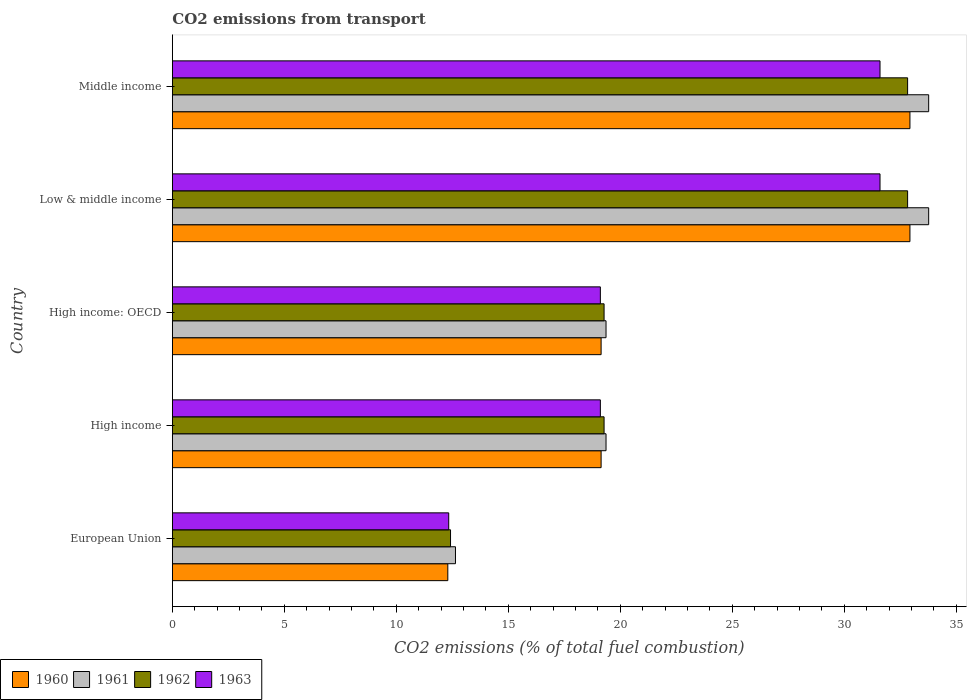How many groups of bars are there?
Give a very brief answer. 5. Are the number of bars on each tick of the Y-axis equal?
Offer a terse response. Yes. How many bars are there on the 5th tick from the top?
Your answer should be compact. 4. How many bars are there on the 1st tick from the bottom?
Keep it short and to the point. 4. What is the label of the 3rd group of bars from the top?
Offer a terse response. High income: OECD. In how many cases, is the number of bars for a given country not equal to the number of legend labels?
Keep it short and to the point. 0. What is the total CO2 emitted in 1960 in European Union?
Ensure brevity in your answer.  12.3. Across all countries, what is the maximum total CO2 emitted in 1963?
Offer a very short reply. 31.59. Across all countries, what is the minimum total CO2 emitted in 1961?
Your answer should be very brief. 12.64. In which country was the total CO2 emitted in 1960 minimum?
Offer a very short reply. European Union. What is the total total CO2 emitted in 1962 in the graph?
Ensure brevity in your answer.  116.61. What is the difference between the total CO2 emitted in 1961 in European Union and that in Low & middle income?
Offer a very short reply. -21.13. What is the difference between the total CO2 emitted in 1960 in High income and the total CO2 emitted in 1961 in High income: OECD?
Give a very brief answer. -0.22. What is the average total CO2 emitted in 1962 per country?
Provide a short and direct response. 23.32. What is the difference between the total CO2 emitted in 1963 and total CO2 emitted in 1961 in High income: OECD?
Your response must be concise. -0.25. In how many countries, is the total CO2 emitted in 1960 greater than 13 ?
Make the answer very short. 4. What is the ratio of the total CO2 emitted in 1963 in European Union to that in High income?
Ensure brevity in your answer.  0.65. Is the total CO2 emitted in 1963 in European Union less than that in Low & middle income?
Ensure brevity in your answer.  Yes. Is the difference between the total CO2 emitted in 1963 in European Union and High income greater than the difference between the total CO2 emitted in 1961 in European Union and High income?
Your response must be concise. No. What is the difference between the highest and the second highest total CO2 emitted in 1962?
Offer a terse response. 0. What is the difference between the highest and the lowest total CO2 emitted in 1961?
Offer a very short reply. 21.13. Is the sum of the total CO2 emitted in 1962 in High income: OECD and Middle income greater than the maximum total CO2 emitted in 1963 across all countries?
Offer a terse response. Yes. Is it the case that in every country, the sum of the total CO2 emitted in 1962 and total CO2 emitted in 1963 is greater than the sum of total CO2 emitted in 1961 and total CO2 emitted in 1960?
Give a very brief answer. No. What does the 3rd bar from the top in High income: OECD represents?
Provide a succinct answer. 1961. How many bars are there?
Offer a very short reply. 20. Are all the bars in the graph horizontal?
Your answer should be very brief. Yes. How many countries are there in the graph?
Keep it short and to the point. 5. Are the values on the major ticks of X-axis written in scientific E-notation?
Your answer should be very brief. No. Does the graph contain any zero values?
Offer a terse response. No. Does the graph contain grids?
Offer a very short reply. No. What is the title of the graph?
Your answer should be compact. CO2 emissions from transport. Does "2009" appear as one of the legend labels in the graph?
Ensure brevity in your answer.  No. What is the label or title of the X-axis?
Give a very brief answer. CO2 emissions (% of total fuel combustion). What is the label or title of the Y-axis?
Your response must be concise. Country. What is the CO2 emissions (% of total fuel combustion) of 1960 in European Union?
Keep it short and to the point. 12.3. What is the CO2 emissions (% of total fuel combustion) in 1961 in European Union?
Offer a terse response. 12.64. What is the CO2 emissions (% of total fuel combustion) in 1962 in European Union?
Your response must be concise. 12.42. What is the CO2 emissions (% of total fuel combustion) in 1963 in European Union?
Ensure brevity in your answer.  12.34. What is the CO2 emissions (% of total fuel combustion) in 1960 in High income?
Make the answer very short. 19.14. What is the CO2 emissions (% of total fuel combustion) of 1961 in High income?
Provide a succinct answer. 19.36. What is the CO2 emissions (% of total fuel combustion) of 1962 in High income?
Your response must be concise. 19.27. What is the CO2 emissions (% of total fuel combustion) in 1963 in High income?
Provide a short and direct response. 19.11. What is the CO2 emissions (% of total fuel combustion) in 1960 in High income: OECD?
Your answer should be very brief. 19.14. What is the CO2 emissions (% of total fuel combustion) of 1961 in High income: OECD?
Keep it short and to the point. 19.36. What is the CO2 emissions (% of total fuel combustion) in 1962 in High income: OECD?
Ensure brevity in your answer.  19.27. What is the CO2 emissions (% of total fuel combustion) of 1963 in High income: OECD?
Provide a short and direct response. 19.11. What is the CO2 emissions (% of total fuel combustion) in 1960 in Low & middle income?
Ensure brevity in your answer.  32.93. What is the CO2 emissions (% of total fuel combustion) in 1961 in Low & middle income?
Your answer should be compact. 33.76. What is the CO2 emissions (% of total fuel combustion) in 1962 in Low & middle income?
Your answer should be compact. 32.82. What is the CO2 emissions (% of total fuel combustion) of 1963 in Low & middle income?
Your answer should be compact. 31.59. What is the CO2 emissions (% of total fuel combustion) of 1960 in Middle income?
Offer a terse response. 32.93. What is the CO2 emissions (% of total fuel combustion) in 1961 in Middle income?
Provide a short and direct response. 33.76. What is the CO2 emissions (% of total fuel combustion) of 1962 in Middle income?
Offer a terse response. 32.82. What is the CO2 emissions (% of total fuel combustion) in 1963 in Middle income?
Provide a succinct answer. 31.59. Across all countries, what is the maximum CO2 emissions (% of total fuel combustion) of 1960?
Your answer should be very brief. 32.93. Across all countries, what is the maximum CO2 emissions (% of total fuel combustion) in 1961?
Offer a very short reply. 33.76. Across all countries, what is the maximum CO2 emissions (% of total fuel combustion) in 1962?
Offer a very short reply. 32.82. Across all countries, what is the maximum CO2 emissions (% of total fuel combustion) in 1963?
Your answer should be compact. 31.59. Across all countries, what is the minimum CO2 emissions (% of total fuel combustion) of 1960?
Offer a very short reply. 12.3. Across all countries, what is the minimum CO2 emissions (% of total fuel combustion) in 1961?
Provide a short and direct response. 12.64. Across all countries, what is the minimum CO2 emissions (% of total fuel combustion) of 1962?
Make the answer very short. 12.42. Across all countries, what is the minimum CO2 emissions (% of total fuel combustion) of 1963?
Your answer should be compact. 12.34. What is the total CO2 emissions (% of total fuel combustion) of 1960 in the graph?
Provide a short and direct response. 116.44. What is the total CO2 emissions (% of total fuel combustion) in 1961 in the graph?
Offer a very short reply. 118.89. What is the total CO2 emissions (% of total fuel combustion) in 1962 in the graph?
Provide a succinct answer. 116.61. What is the total CO2 emissions (% of total fuel combustion) in 1963 in the graph?
Your response must be concise. 113.74. What is the difference between the CO2 emissions (% of total fuel combustion) of 1960 in European Union and that in High income?
Your answer should be compact. -6.84. What is the difference between the CO2 emissions (% of total fuel combustion) of 1961 in European Union and that in High income?
Ensure brevity in your answer.  -6.72. What is the difference between the CO2 emissions (% of total fuel combustion) in 1962 in European Union and that in High income?
Your answer should be very brief. -6.86. What is the difference between the CO2 emissions (% of total fuel combustion) of 1963 in European Union and that in High income?
Provide a short and direct response. -6.77. What is the difference between the CO2 emissions (% of total fuel combustion) of 1960 in European Union and that in High income: OECD?
Make the answer very short. -6.84. What is the difference between the CO2 emissions (% of total fuel combustion) of 1961 in European Union and that in High income: OECD?
Give a very brief answer. -6.72. What is the difference between the CO2 emissions (% of total fuel combustion) of 1962 in European Union and that in High income: OECD?
Ensure brevity in your answer.  -6.86. What is the difference between the CO2 emissions (% of total fuel combustion) in 1963 in European Union and that in High income: OECD?
Offer a very short reply. -6.77. What is the difference between the CO2 emissions (% of total fuel combustion) in 1960 in European Union and that in Low & middle income?
Your answer should be compact. -20.63. What is the difference between the CO2 emissions (% of total fuel combustion) of 1961 in European Union and that in Low & middle income?
Give a very brief answer. -21.13. What is the difference between the CO2 emissions (% of total fuel combustion) of 1962 in European Union and that in Low & middle income?
Give a very brief answer. -20.41. What is the difference between the CO2 emissions (% of total fuel combustion) in 1963 in European Union and that in Low & middle income?
Your answer should be very brief. -19.25. What is the difference between the CO2 emissions (% of total fuel combustion) in 1960 in European Union and that in Middle income?
Provide a succinct answer. -20.63. What is the difference between the CO2 emissions (% of total fuel combustion) in 1961 in European Union and that in Middle income?
Offer a very short reply. -21.13. What is the difference between the CO2 emissions (% of total fuel combustion) in 1962 in European Union and that in Middle income?
Offer a terse response. -20.41. What is the difference between the CO2 emissions (% of total fuel combustion) in 1963 in European Union and that in Middle income?
Offer a terse response. -19.25. What is the difference between the CO2 emissions (% of total fuel combustion) in 1962 in High income and that in High income: OECD?
Give a very brief answer. 0. What is the difference between the CO2 emissions (% of total fuel combustion) in 1963 in High income and that in High income: OECD?
Your answer should be compact. 0. What is the difference between the CO2 emissions (% of total fuel combustion) in 1960 in High income and that in Low & middle income?
Offer a very short reply. -13.79. What is the difference between the CO2 emissions (% of total fuel combustion) of 1961 in High income and that in Low & middle income?
Offer a very short reply. -14.4. What is the difference between the CO2 emissions (% of total fuel combustion) in 1962 in High income and that in Low & middle income?
Provide a short and direct response. -13.55. What is the difference between the CO2 emissions (% of total fuel combustion) in 1963 in High income and that in Low & middle income?
Make the answer very short. -12.48. What is the difference between the CO2 emissions (% of total fuel combustion) of 1960 in High income and that in Middle income?
Provide a succinct answer. -13.79. What is the difference between the CO2 emissions (% of total fuel combustion) of 1961 in High income and that in Middle income?
Offer a terse response. -14.4. What is the difference between the CO2 emissions (% of total fuel combustion) in 1962 in High income and that in Middle income?
Ensure brevity in your answer.  -13.55. What is the difference between the CO2 emissions (% of total fuel combustion) in 1963 in High income and that in Middle income?
Your answer should be compact. -12.48. What is the difference between the CO2 emissions (% of total fuel combustion) of 1960 in High income: OECD and that in Low & middle income?
Offer a terse response. -13.79. What is the difference between the CO2 emissions (% of total fuel combustion) in 1961 in High income: OECD and that in Low & middle income?
Your response must be concise. -14.4. What is the difference between the CO2 emissions (% of total fuel combustion) in 1962 in High income: OECD and that in Low & middle income?
Offer a terse response. -13.55. What is the difference between the CO2 emissions (% of total fuel combustion) in 1963 in High income: OECD and that in Low & middle income?
Keep it short and to the point. -12.48. What is the difference between the CO2 emissions (% of total fuel combustion) of 1960 in High income: OECD and that in Middle income?
Your response must be concise. -13.79. What is the difference between the CO2 emissions (% of total fuel combustion) in 1961 in High income: OECD and that in Middle income?
Offer a very short reply. -14.4. What is the difference between the CO2 emissions (% of total fuel combustion) in 1962 in High income: OECD and that in Middle income?
Offer a very short reply. -13.55. What is the difference between the CO2 emissions (% of total fuel combustion) in 1963 in High income: OECD and that in Middle income?
Offer a terse response. -12.48. What is the difference between the CO2 emissions (% of total fuel combustion) of 1961 in Low & middle income and that in Middle income?
Your response must be concise. 0. What is the difference between the CO2 emissions (% of total fuel combustion) of 1960 in European Union and the CO2 emissions (% of total fuel combustion) of 1961 in High income?
Provide a succinct answer. -7.06. What is the difference between the CO2 emissions (% of total fuel combustion) of 1960 in European Union and the CO2 emissions (% of total fuel combustion) of 1962 in High income?
Provide a short and direct response. -6.98. What is the difference between the CO2 emissions (% of total fuel combustion) in 1960 in European Union and the CO2 emissions (% of total fuel combustion) in 1963 in High income?
Ensure brevity in your answer.  -6.81. What is the difference between the CO2 emissions (% of total fuel combustion) in 1961 in European Union and the CO2 emissions (% of total fuel combustion) in 1962 in High income?
Keep it short and to the point. -6.64. What is the difference between the CO2 emissions (% of total fuel combustion) in 1961 in European Union and the CO2 emissions (% of total fuel combustion) in 1963 in High income?
Your response must be concise. -6.47. What is the difference between the CO2 emissions (% of total fuel combustion) of 1962 in European Union and the CO2 emissions (% of total fuel combustion) of 1963 in High income?
Offer a terse response. -6.69. What is the difference between the CO2 emissions (% of total fuel combustion) of 1960 in European Union and the CO2 emissions (% of total fuel combustion) of 1961 in High income: OECD?
Your answer should be very brief. -7.06. What is the difference between the CO2 emissions (% of total fuel combustion) in 1960 in European Union and the CO2 emissions (% of total fuel combustion) in 1962 in High income: OECD?
Ensure brevity in your answer.  -6.98. What is the difference between the CO2 emissions (% of total fuel combustion) in 1960 in European Union and the CO2 emissions (% of total fuel combustion) in 1963 in High income: OECD?
Keep it short and to the point. -6.81. What is the difference between the CO2 emissions (% of total fuel combustion) in 1961 in European Union and the CO2 emissions (% of total fuel combustion) in 1962 in High income: OECD?
Your answer should be compact. -6.64. What is the difference between the CO2 emissions (% of total fuel combustion) in 1961 in European Union and the CO2 emissions (% of total fuel combustion) in 1963 in High income: OECD?
Your answer should be compact. -6.47. What is the difference between the CO2 emissions (% of total fuel combustion) of 1962 in European Union and the CO2 emissions (% of total fuel combustion) of 1963 in High income: OECD?
Make the answer very short. -6.69. What is the difference between the CO2 emissions (% of total fuel combustion) in 1960 in European Union and the CO2 emissions (% of total fuel combustion) in 1961 in Low & middle income?
Your answer should be very brief. -21.47. What is the difference between the CO2 emissions (% of total fuel combustion) in 1960 in European Union and the CO2 emissions (% of total fuel combustion) in 1962 in Low & middle income?
Keep it short and to the point. -20.53. What is the difference between the CO2 emissions (% of total fuel combustion) in 1960 in European Union and the CO2 emissions (% of total fuel combustion) in 1963 in Low & middle income?
Provide a succinct answer. -19.29. What is the difference between the CO2 emissions (% of total fuel combustion) in 1961 in European Union and the CO2 emissions (% of total fuel combustion) in 1962 in Low & middle income?
Your answer should be very brief. -20.19. What is the difference between the CO2 emissions (% of total fuel combustion) of 1961 in European Union and the CO2 emissions (% of total fuel combustion) of 1963 in Low & middle income?
Make the answer very short. -18.95. What is the difference between the CO2 emissions (% of total fuel combustion) of 1962 in European Union and the CO2 emissions (% of total fuel combustion) of 1963 in Low & middle income?
Offer a very short reply. -19.17. What is the difference between the CO2 emissions (% of total fuel combustion) of 1960 in European Union and the CO2 emissions (% of total fuel combustion) of 1961 in Middle income?
Offer a very short reply. -21.47. What is the difference between the CO2 emissions (% of total fuel combustion) in 1960 in European Union and the CO2 emissions (% of total fuel combustion) in 1962 in Middle income?
Provide a succinct answer. -20.53. What is the difference between the CO2 emissions (% of total fuel combustion) of 1960 in European Union and the CO2 emissions (% of total fuel combustion) of 1963 in Middle income?
Your answer should be very brief. -19.29. What is the difference between the CO2 emissions (% of total fuel combustion) in 1961 in European Union and the CO2 emissions (% of total fuel combustion) in 1962 in Middle income?
Make the answer very short. -20.19. What is the difference between the CO2 emissions (% of total fuel combustion) in 1961 in European Union and the CO2 emissions (% of total fuel combustion) in 1963 in Middle income?
Your answer should be compact. -18.95. What is the difference between the CO2 emissions (% of total fuel combustion) of 1962 in European Union and the CO2 emissions (% of total fuel combustion) of 1963 in Middle income?
Your answer should be compact. -19.17. What is the difference between the CO2 emissions (% of total fuel combustion) of 1960 in High income and the CO2 emissions (% of total fuel combustion) of 1961 in High income: OECD?
Offer a terse response. -0.22. What is the difference between the CO2 emissions (% of total fuel combustion) of 1960 in High income and the CO2 emissions (% of total fuel combustion) of 1962 in High income: OECD?
Your response must be concise. -0.13. What is the difference between the CO2 emissions (% of total fuel combustion) of 1960 in High income and the CO2 emissions (% of total fuel combustion) of 1963 in High income: OECD?
Your answer should be very brief. 0.03. What is the difference between the CO2 emissions (% of total fuel combustion) in 1961 in High income and the CO2 emissions (% of total fuel combustion) in 1962 in High income: OECD?
Your answer should be compact. 0.09. What is the difference between the CO2 emissions (% of total fuel combustion) of 1961 in High income and the CO2 emissions (% of total fuel combustion) of 1963 in High income: OECD?
Provide a short and direct response. 0.25. What is the difference between the CO2 emissions (% of total fuel combustion) of 1962 in High income and the CO2 emissions (% of total fuel combustion) of 1963 in High income: OECD?
Give a very brief answer. 0.17. What is the difference between the CO2 emissions (% of total fuel combustion) of 1960 in High income and the CO2 emissions (% of total fuel combustion) of 1961 in Low & middle income?
Keep it short and to the point. -14.62. What is the difference between the CO2 emissions (% of total fuel combustion) in 1960 in High income and the CO2 emissions (% of total fuel combustion) in 1962 in Low & middle income?
Make the answer very short. -13.68. What is the difference between the CO2 emissions (% of total fuel combustion) in 1960 in High income and the CO2 emissions (% of total fuel combustion) in 1963 in Low & middle income?
Your response must be concise. -12.45. What is the difference between the CO2 emissions (% of total fuel combustion) in 1961 in High income and the CO2 emissions (% of total fuel combustion) in 1962 in Low & middle income?
Offer a very short reply. -13.46. What is the difference between the CO2 emissions (% of total fuel combustion) of 1961 in High income and the CO2 emissions (% of total fuel combustion) of 1963 in Low & middle income?
Make the answer very short. -12.23. What is the difference between the CO2 emissions (% of total fuel combustion) of 1962 in High income and the CO2 emissions (% of total fuel combustion) of 1963 in Low & middle income?
Keep it short and to the point. -12.32. What is the difference between the CO2 emissions (% of total fuel combustion) in 1960 in High income and the CO2 emissions (% of total fuel combustion) in 1961 in Middle income?
Your answer should be compact. -14.62. What is the difference between the CO2 emissions (% of total fuel combustion) in 1960 in High income and the CO2 emissions (% of total fuel combustion) in 1962 in Middle income?
Offer a terse response. -13.68. What is the difference between the CO2 emissions (% of total fuel combustion) of 1960 in High income and the CO2 emissions (% of total fuel combustion) of 1963 in Middle income?
Your answer should be compact. -12.45. What is the difference between the CO2 emissions (% of total fuel combustion) of 1961 in High income and the CO2 emissions (% of total fuel combustion) of 1962 in Middle income?
Your answer should be very brief. -13.46. What is the difference between the CO2 emissions (% of total fuel combustion) of 1961 in High income and the CO2 emissions (% of total fuel combustion) of 1963 in Middle income?
Your answer should be compact. -12.23. What is the difference between the CO2 emissions (% of total fuel combustion) in 1962 in High income and the CO2 emissions (% of total fuel combustion) in 1963 in Middle income?
Your answer should be very brief. -12.32. What is the difference between the CO2 emissions (% of total fuel combustion) of 1960 in High income: OECD and the CO2 emissions (% of total fuel combustion) of 1961 in Low & middle income?
Ensure brevity in your answer.  -14.62. What is the difference between the CO2 emissions (% of total fuel combustion) of 1960 in High income: OECD and the CO2 emissions (% of total fuel combustion) of 1962 in Low & middle income?
Your answer should be compact. -13.68. What is the difference between the CO2 emissions (% of total fuel combustion) of 1960 in High income: OECD and the CO2 emissions (% of total fuel combustion) of 1963 in Low & middle income?
Your answer should be compact. -12.45. What is the difference between the CO2 emissions (% of total fuel combustion) of 1961 in High income: OECD and the CO2 emissions (% of total fuel combustion) of 1962 in Low & middle income?
Make the answer very short. -13.46. What is the difference between the CO2 emissions (% of total fuel combustion) of 1961 in High income: OECD and the CO2 emissions (% of total fuel combustion) of 1963 in Low & middle income?
Provide a succinct answer. -12.23. What is the difference between the CO2 emissions (% of total fuel combustion) in 1962 in High income: OECD and the CO2 emissions (% of total fuel combustion) in 1963 in Low & middle income?
Ensure brevity in your answer.  -12.32. What is the difference between the CO2 emissions (% of total fuel combustion) in 1960 in High income: OECD and the CO2 emissions (% of total fuel combustion) in 1961 in Middle income?
Your answer should be compact. -14.62. What is the difference between the CO2 emissions (% of total fuel combustion) of 1960 in High income: OECD and the CO2 emissions (% of total fuel combustion) of 1962 in Middle income?
Your answer should be compact. -13.68. What is the difference between the CO2 emissions (% of total fuel combustion) of 1960 in High income: OECD and the CO2 emissions (% of total fuel combustion) of 1963 in Middle income?
Your answer should be compact. -12.45. What is the difference between the CO2 emissions (% of total fuel combustion) in 1961 in High income: OECD and the CO2 emissions (% of total fuel combustion) in 1962 in Middle income?
Your answer should be compact. -13.46. What is the difference between the CO2 emissions (% of total fuel combustion) of 1961 in High income: OECD and the CO2 emissions (% of total fuel combustion) of 1963 in Middle income?
Make the answer very short. -12.23. What is the difference between the CO2 emissions (% of total fuel combustion) of 1962 in High income: OECD and the CO2 emissions (% of total fuel combustion) of 1963 in Middle income?
Offer a terse response. -12.32. What is the difference between the CO2 emissions (% of total fuel combustion) in 1960 in Low & middle income and the CO2 emissions (% of total fuel combustion) in 1961 in Middle income?
Offer a very short reply. -0.84. What is the difference between the CO2 emissions (% of total fuel combustion) of 1960 in Low & middle income and the CO2 emissions (% of total fuel combustion) of 1962 in Middle income?
Your answer should be compact. 0.1. What is the difference between the CO2 emissions (% of total fuel combustion) in 1960 in Low & middle income and the CO2 emissions (% of total fuel combustion) in 1963 in Middle income?
Make the answer very short. 1.34. What is the difference between the CO2 emissions (% of total fuel combustion) of 1961 in Low & middle income and the CO2 emissions (% of total fuel combustion) of 1962 in Middle income?
Offer a terse response. 0.94. What is the difference between the CO2 emissions (% of total fuel combustion) of 1961 in Low & middle income and the CO2 emissions (% of total fuel combustion) of 1963 in Middle income?
Ensure brevity in your answer.  2.17. What is the difference between the CO2 emissions (% of total fuel combustion) of 1962 in Low & middle income and the CO2 emissions (% of total fuel combustion) of 1963 in Middle income?
Ensure brevity in your answer.  1.23. What is the average CO2 emissions (% of total fuel combustion) of 1960 per country?
Provide a short and direct response. 23.29. What is the average CO2 emissions (% of total fuel combustion) of 1961 per country?
Make the answer very short. 23.78. What is the average CO2 emissions (% of total fuel combustion) of 1962 per country?
Ensure brevity in your answer.  23.32. What is the average CO2 emissions (% of total fuel combustion) in 1963 per country?
Provide a short and direct response. 22.75. What is the difference between the CO2 emissions (% of total fuel combustion) in 1960 and CO2 emissions (% of total fuel combustion) in 1961 in European Union?
Provide a succinct answer. -0.34. What is the difference between the CO2 emissions (% of total fuel combustion) in 1960 and CO2 emissions (% of total fuel combustion) in 1962 in European Union?
Your answer should be compact. -0.12. What is the difference between the CO2 emissions (% of total fuel combustion) in 1960 and CO2 emissions (% of total fuel combustion) in 1963 in European Union?
Keep it short and to the point. -0.04. What is the difference between the CO2 emissions (% of total fuel combustion) in 1961 and CO2 emissions (% of total fuel combustion) in 1962 in European Union?
Your response must be concise. 0.22. What is the difference between the CO2 emissions (% of total fuel combustion) of 1961 and CO2 emissions (% of total fuel combustion) of 1963 in European Union?
Your response must be concise. 0.3. What is the difference between the CO2 emissions (% of total fuel combustion) in 1962 and CO2 emissions (% of total fuel combustion) in 1963 in European Union?
Give a very brief answer. 0.08. What is the difference between the CO2 emissions (% of total fuel combustion) in 1960 and CO2 emissions (% of total fuel combustion) in 1961 in High income?
Your answer should be compact. -0.22. What is the difference between the CO2 emissions (% of total fuel combustion) of 1960 and CO2 emissions (% of total fuel combustion) of 1962 in High income?
Offer a very short reply. -0.13. What is the difference between the CO2 emissions (% of total fuel combustion) in 1960 and CO2 emissions (% of total fuel combustion) in 1963 in High income?
Your answer should be very brief. 0.03. What is the difference between the CO2 emissions (% of total fuel combustion) of 1961 and CO2 emissions (% of total fuel combustion) of 1962 in High income?
Your response must be concise. 0.09. What is the difference between the CO2 emissions (% of total fuel combustion) of 1961 and CO2 emissions (% of total fuel combustion) of 1963 in High income?
Offer a terse response. 0.25. What is the difference between the CO2 emissions (% of total fuel combustion) of 1962 and CO2 emissions (% of total fuel combustion) of 1963 in High income?
Your response must be concise. 0.17. What is the difference between the CO2 emissions (% of total fuel combustion) in 1960 and CO2 emissions (% of total fuel combustion) in 1961 in High income: OECD?
Offer a terse response. -0.22. What is the difference between the CO2 emissions (% of total fuel combustion) of 1960 and CO2 emissions (% of total fuel combustion) of 1962 in High income: OECD?
Keep it short and to the point. -0.13. What is the difference between the CO2 emissions (% of total fuel combustion) of 1960 and CO2 emissions (% of total fuel combustion) of 1963 in High income: OECD?
Your answer should be compact. 0.03. What is the difference between the CO2 emissions (% of total fuel combustion) of 1961 and CO2 emissions (% of total fuel combustion) of 1962 in High income: OECD?
Provide a succinct answer. 0.09. What is the difference between the CO2 emissions (% of total fuel combustion) in 1961 and CO2 emissions (% of total fuel combustion) in 1963 in High income: OECD?
Give a very brief answer. 0.25. What is the difference between the CO2 emissions (% of total fuel combustion) in 1962 and CO2 emissions (% of total fuel combustion) in 1963 in High income: OECD?
Provide a short and direct response. 0.17. What is the difference between the CO2 emissions (% of total fuel combustion) in 1960 and CO2 emissions (% of total fuel combustion) in 1961 in Low & middle income?
Offer a terse response. -0.84. What is the difference between the CO2 emissions (% of total fuel combustion) of 1960 and CO2 emissions (% of total fuel combustion) of 1962 in Low & middle income?
Provide a short and direct response. 0.1. What is the difference between the CO2 emissions (% of total fuel combustion) of 1960 and CO2 emissions (% of total fuel combustion) of 1963 in Low & middle income?
Your response must be concise. 1.34. What is the difference between the CO2 emissions (% of total fuel combustion) of 1961 and CO2 emissions (% of total fuel combustion) of 1962 in Low & middle income?
Provide a succinct answer. 0.94. What is the difference between the CO2 emissions (% of total fuel combustion) of 1961 and CO2 emissions (% of total fuel combustion) of 1963 in Low & middle income?
Your answer should be compact. 2.17. What is the difference between the CO2 emissions (% of total fuel combustion) in 1962 and CO2 emissions (% of total fuel combustion) in 1963 in Low & middle income?
Keep it short and to the point. 1.23. What is the difference between the CO2 emissions (% of total fuel combustion) in 1960 and CO2 emissions (% of total fuel combustion) in 1961 in Middle income?
Give a very brief answer. -0.84. What is the difference between the CO2 emissions (% of total fuel combustion) of 1960 and CO2 emissions (% of total fuel combustion) of 1962 in Middle income?
Your answer should be compact. 0.1. What is the difference between the CO2 emissions (% of total fuel combustion) of 1960 and CO2 emissions (% of total fuel combustion) of 1963 in Middle income?
Provide a succinct answer. 1.34. What is the difference between the CO2 emissions (% of total fuel combustion) in 1961 and CO2 emissions (% of total fuel combustion) in 1962 in Middle income?
Your response must be concise. 0.94. What is the difference between the CO2 emissions (% of total fuel combustion) in 1961 and CO2 emissions (% of total fuel combustion) in 1963 in Middle income?
Provide a short and direct response. 2.17. What is the difference between the CO2 emissions (% of total fuel combustion) of 1962 and CO2 emissions (% of total fuel combustion) of 1963 in Middle income?
Your answer should be very brief. 1.23. What is the ratio of the CO2 emissions (% of total fuel combustion) of 1960 in European Union to that in High income?
Offer a terse response. 0.64. What is the ratio of the CO2 emissions (% of total fuel combustion) of 1961 in European Union to that in High income?
Your answer should be very brief. 0.65. What is the ratio of the CO2 emissions (% of total fuel combustion) in 1962 in European Union to that in High income?
Your answer should be compact. 0.64. What is the ratio of the CO2 emissions (% of total fuel combustion) in 1963 in European Union to that in High income?
Your answer should be compact. 0.65. What is the ratio of the CO2 emissions (% of total fuel combustion) of 1960 in European Union to that in High income: OECD?
Offer a very short reply. 0.64. What is the ratio of the CO2 emissions (% of total fuel combustion) of 1961 in European Union to that in High income: OECD?
Keep it short and to the point. 0.65. What is the ratio of the CO2 emissions (% of total fuel combustion) of 1962 in European Union to that in High income: OECD?
Your answer should be very brief. 0.64. What is the ratio of the CO2 emissions (% of total fuel combustion) in 1963 in European Union to that in High income: OECD?
Provide a short and direct response. 0.65. What is the ratio of the CO2 emissions (% of total fuel combustion) of 1960 in European Union to that in Low & middle income?
Your answer should be compact. 0.37. What is the ratio of the CO2 emissions (% of total fuel combustion) in 1961 in European Union to that in Low & middle income?
Give a very brief answer. 0.37. What is the ratio of the CO2 emissions (% of total fuel combustion) in 1962 in European Union to that in Low & middle income?
Your response must be concise. 0.38. What is the ratio of the CO2 emissions (% of total fuel combustion) in 1963 in European Union to that in Low & middle income?
Offer a terse response. 0.39. What is the ratio of the CO2 emissions (% of total fuel combustion) of 1960 in European Union to that in Middle income?
Give a very brief answer. 0.37. What is the ratio of the CO2 emissions (% of total fuel combustion) of 1961 in European Union to that in Middle income?
Provide a succinct answer. 0.37. What is the ratio of the CO2 emissions (% of total fuel combustion) in 1962 in European Union to that in Middle income?
Ensure brevity in your answer.  0.38. What is the ratio of the CO2 emissions (% of total fuel combustion) in 1963 in European Union to that in Middle income?
Your answer should be compact. 0.39. What is the ratio of the CO2 emissions (% of total fuel combustion) in 1960 in High income to that in High income: OECD?
Keep it short and to the point. 1. What is the ratio of the CO2 emissions (% of total fuel combustion) of 1961 in High income to that in High income: OECD?
Keep it short and to the point. 1. What is the ratio of the CO2 emissions (% of total fuel combustion) of 1962 in High income to that in High income: OECD?
Provide a succinct answer. 1. What is the ratio of the CO2 emissions (% of total fuel combustion) of 1963 in High income to that in High income: OECD?
Make the answer very short. 1. What is the ratio of the CO2 emissions (% of total fuel combustion) of 1960 in High income to that in Low & middle income?
Ensure brevity in your answer.  0.58. What is the ratio of the CO2 emissions (% of total fuel combustion) of 1961 in High income to that in Low & middle income?
Your answer should be very brief. 0.57. What is the ratio of the CO2 emissions (% of total fuel combustion) of 1962 in High income to that in Low & middle income?
Give a very brief answer. 0.59. What is the ratio of the CO2 emissions (% of total fuel combustion) of 1963 in High income to that in Low & middle income?
Offer a terse response. 0.6. What is the ratio of the CO2 emissions (% of total fuel combustion) in 1960 in High income to that in Middle income?
Make the answer very short. 0.58. What is the ratio of the CO2 emissions (% of total fuel combustion) of 1961 in High income to that in Middle income?
Provide a short and direct response. 0.57. What is the ratio of the CO2 emissions (% of total fuel combustion) of 1962 in High income to that in Middle income?
Your answer should be compact. 0.59. What is the ratio of the CO2 emissions (% of total fuel combustion) in 1963 in High income to that in Middle income?
Ensure brevity in your answer.  0.6. What is the ratio of the CO2 emissions (% of total fuel combustion) of 1960 in High income: OECD to that in Low & middle income?
Keep it short and to the point. 0.58. What is the ratio of the CO2 emissions (% of total fuel combustion) in 1961 in High income: OECD to that in Low & middle income?
Provide a short and direct response. 0.57. What is the ratio of the CO2 emissions (% of total fuel combustion) in 1962 in High income: OECD to that in Low & middle income?
Your answer should be compact. 0.59. What is the ratio of the CO2 emissions (% of total fuel combustion) of 1963 in High income: OECD to that in Low & middle income?
Offer a very short reply. 0.6. What is the ratio of the CO2 emissions (% of total fuel combustion) of 1960 in High income: OECD to that in Middle income?
Your response must be concise. 0.58. What is the ratio of the CO2 emissions (% of total fuel combustion) in 1961 in High income: OECD to that in Middle income?
Keep it short and to the point. 0.57. What is the ratio of the CO2 emissions (% of total fuel combustion) in 1962 in High income: OECD to that in Middle income?
Offer a terse response. 0.59. What is the ratio of the CO2 emissions (% of total fuel combustion) in 1963 in High income: OECD to that in Middle income?
Offer a very short reply. 0.6. What is the ratio of the CO2 emissions (% of total fuel combustion) in 1960 in Low & middle income to that in Middle income?
Make the answer very short. 1. What is the ratio of the CO2 emissions (% of total fuel combustion) in 1962 in Low & middle income to that in Middle income?
Offer a very short reply. 1. What is the difference between the highest and the second highest CO2 emissions (% of total fuel combustion) in 1961?
Offer a terse response. 0. What is the difference between the highest and the second highest CO2 emissions (% of total fuel combustion) of 1962?
Provide a succinct answer. 0. What is the difference between the highest and the lowest CO2 emissions (% of total fuel combustion) of 1960?
Offer a terse response. 20.63. What is the difference between the highest and the lowest CO2 emissions (% of total fuel combustion) of 1961?
Keep it short and to the point. 21.13. What is the difference between the highest and the lowest CO2 emissions (% of total fuel combustion) of 1962?
Ensure brevity in your answer.  20.41. What is the difference between the highest and the lowest CO2 emissions (% of total fuel combustion) in 1963?
Make the answer very short. 19.25. 